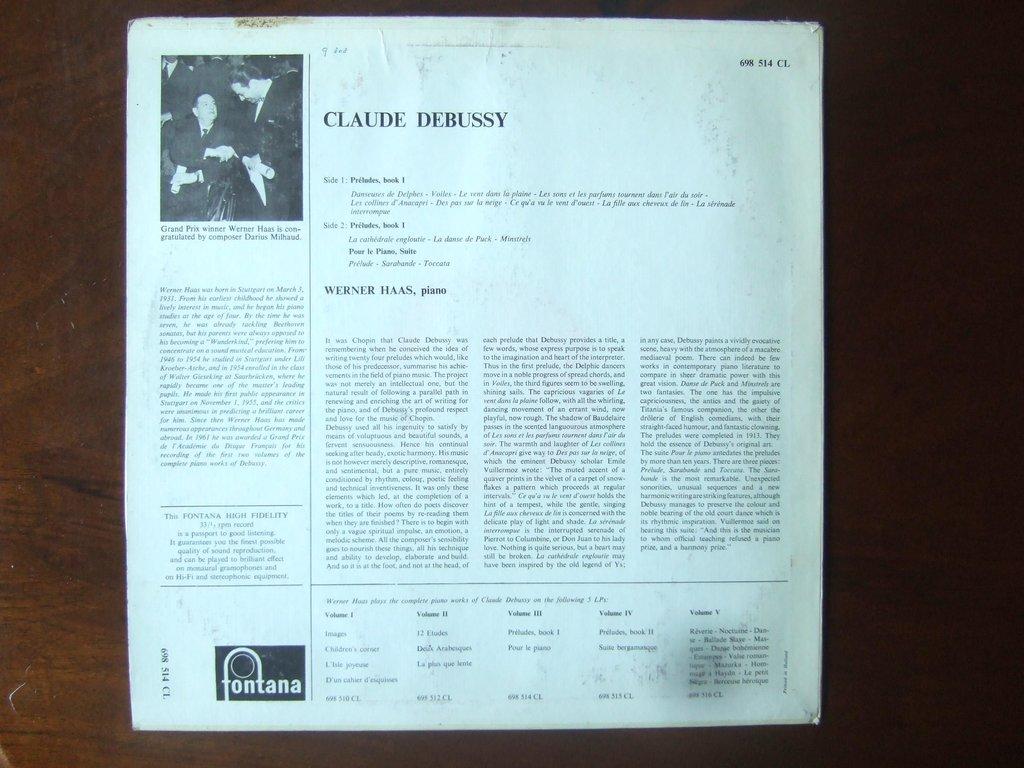What is the composer's name on the album?
Give a very brief answer. Claude debussy. What instrument does the composer play?
Offer a terse response. Piano. 